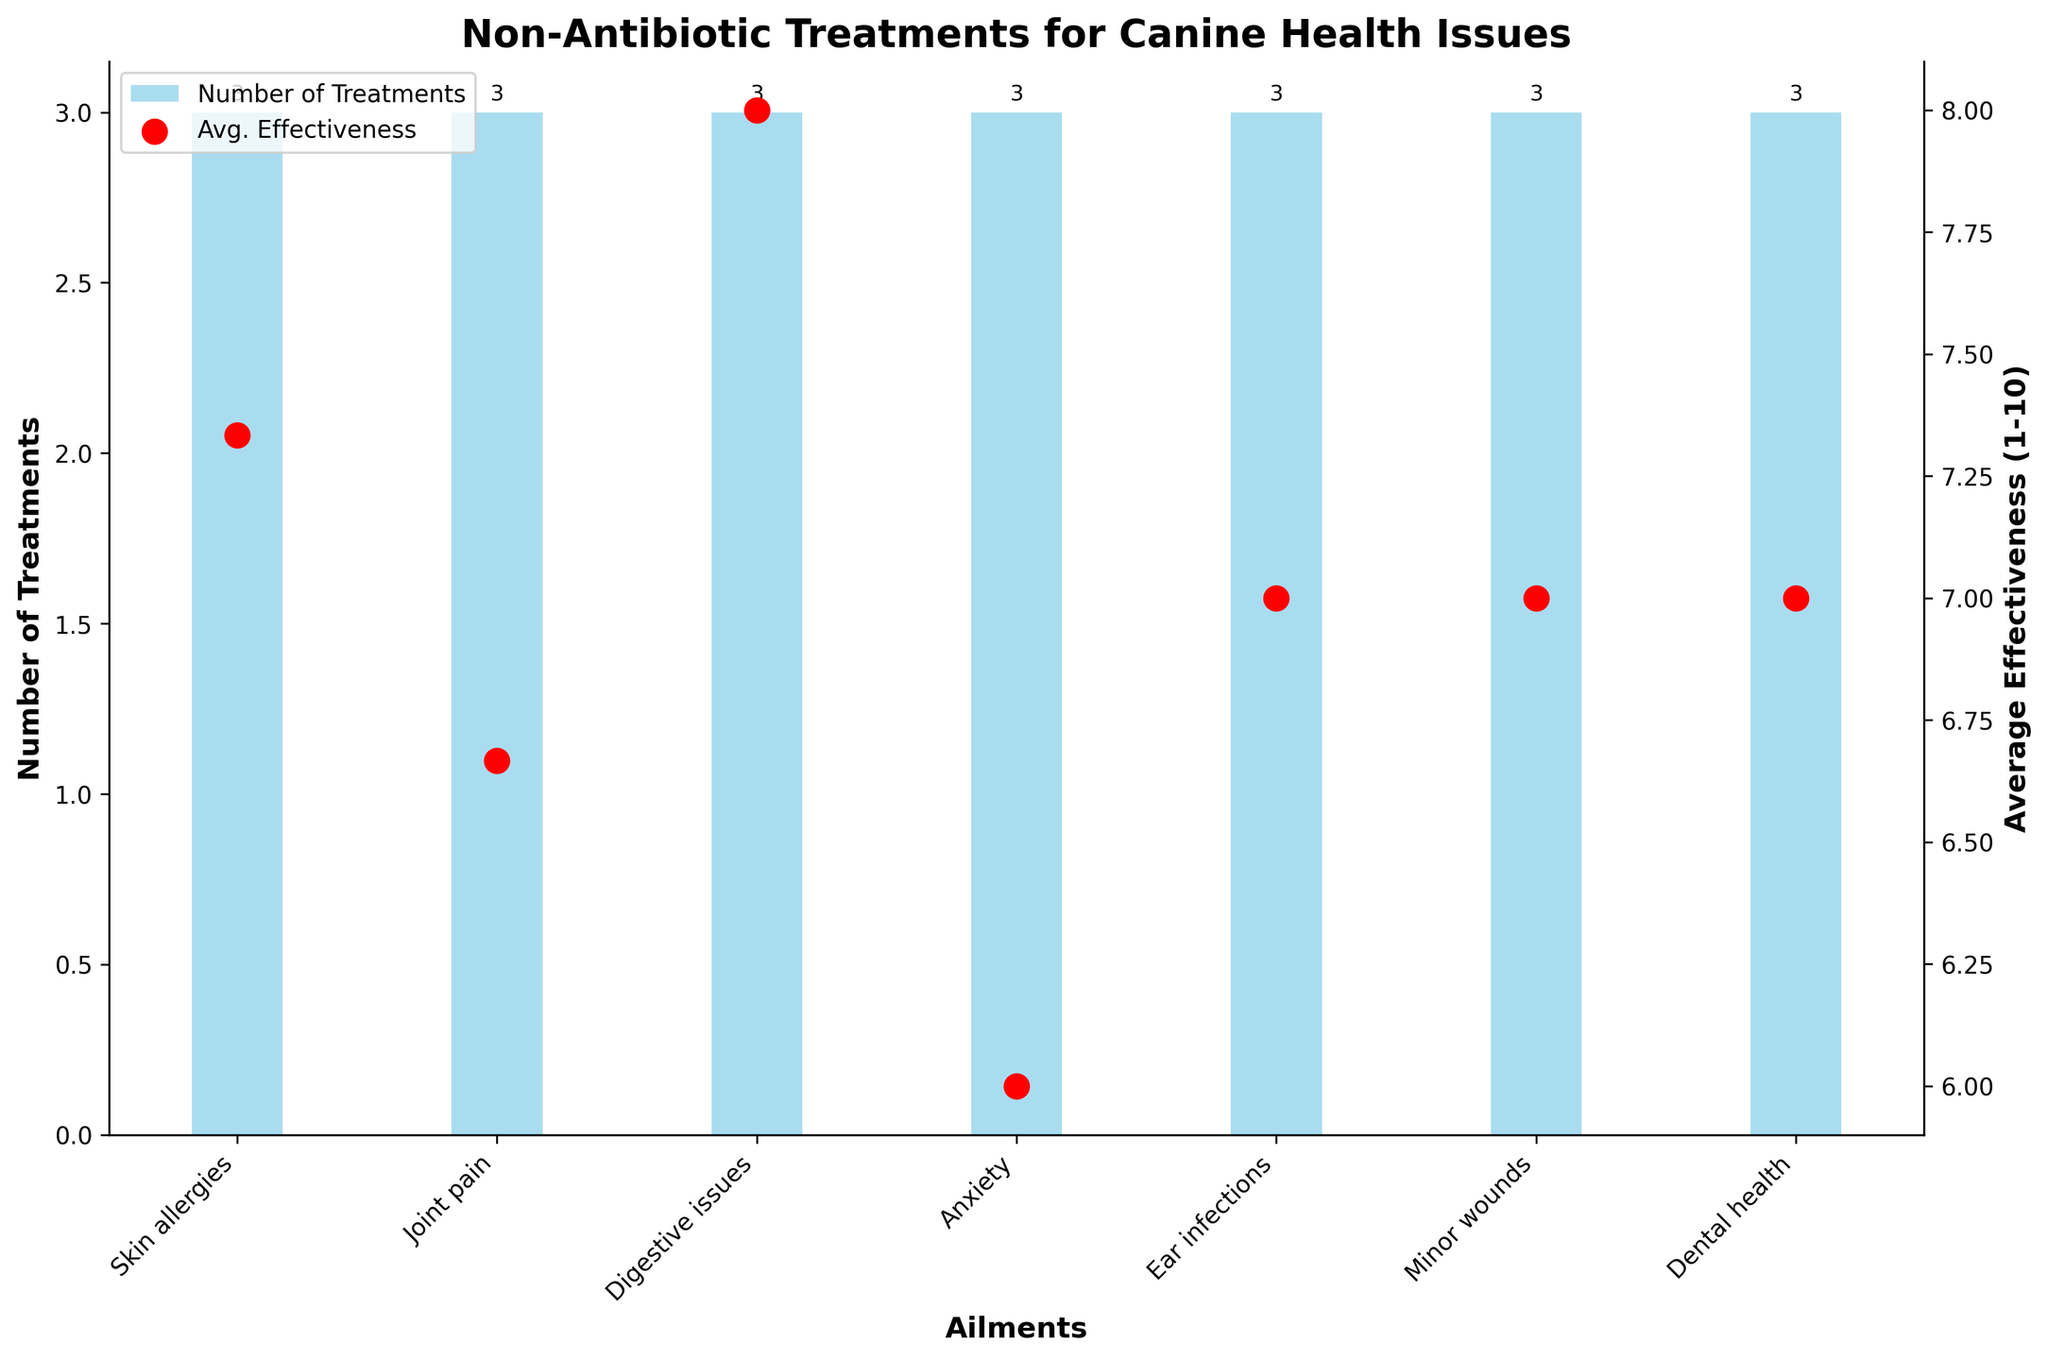What ailment has the highest average effectiveness of treatments? To find the ailment with the highest average effectiveness, we look at the red points on the chart, representing average effectiveness values. The highest red point is above "Anxiety" with an average effectiveness around 9.
Answer: Anxiety How many treatments are available for skin allergies? To determine the number of treatments for skin allergies, we look at the height of the bar corresponding to "Skin allergies" in the blue bars section of the chart. The height indicates 3 treatments.
Answer: 3 Which treatment category has an average effectiveness greater than 8? We need to identify the red points in the chart that are above the line marked at 8 on the secondary (right-hand) vertical axis. Only the "Digestive issues" and "Anxiety" categories have red points above 8.
Answer: Digestive issues, Anxiety Is there any category with both the maximum number of treatments and highest average effectiveness? By examining the blue and red values together, we see that no single category has both the most treatments (which are for "Skin allergies" and "Joint pain", both with 3 treatments) and the highest effectiveness (which is "Anxiety" with an effectiveness of 9).
Answer: No How does the average effectiveness of treatments for dental health compare to those for minor wounds? Comparing the dental health and minor wounds categories, the average effectiveness for dental health is approximately 6.67, while for minor wounds it is around 7. These values come from the red points marking the average effectiveness for each category.
Answer: Minor wounds have higher average effectiveness 